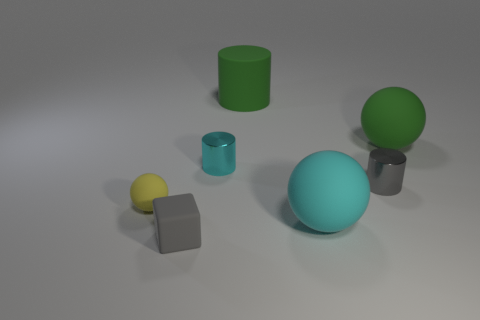What number of tiny cylinders are there?
Make the answer very short. 2. What is the cube that is on the left side of the cyan ball made of?
Ensure brevity in your answer.  Rubber. There is a gray cylinder; are there any gray cylinders in front of it?
Offer a terse response. No. Is the size of the green rubber cylinder the same as the yellow rubber object?
Ensure brevity in your answer.  No. What number of other small spheres are made of the same material as the cyan sphere?
Your response must be concise. 1. There is a thing that is behind the big rubber sphere behind the gray metal thing; how big is it?
Ensure brevity in your answer.  Large. What color is the object that is both in front of the green ball and to the right of the large cyan rubber thing?
Your answer should be compact. Gray. Is the tiny cyan thing the same shape as the small gray metallic object?
Provide a succinct answer. Yes. There is a cylinder that is the same color as the block; what size is it?
Provide a succinct answer. Small. The object on the right side of the cylinder that is in front of the small cyan cylinder is what shape?
Provide a short and direct response. Sphere. 